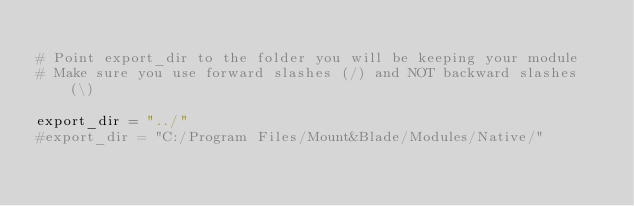Convert code to text. <code><loc_0><loc_0><loc_500><loc_500><_Python_>
# Point export_dir to the folder you will be keeping your module
# Make sure you use forward slashes (/) and NOT backward slashes (\)

export_dir = "../"
#export_dir = "C:/Program Files/Mount&Blade/Modules/Native/"
</code> 